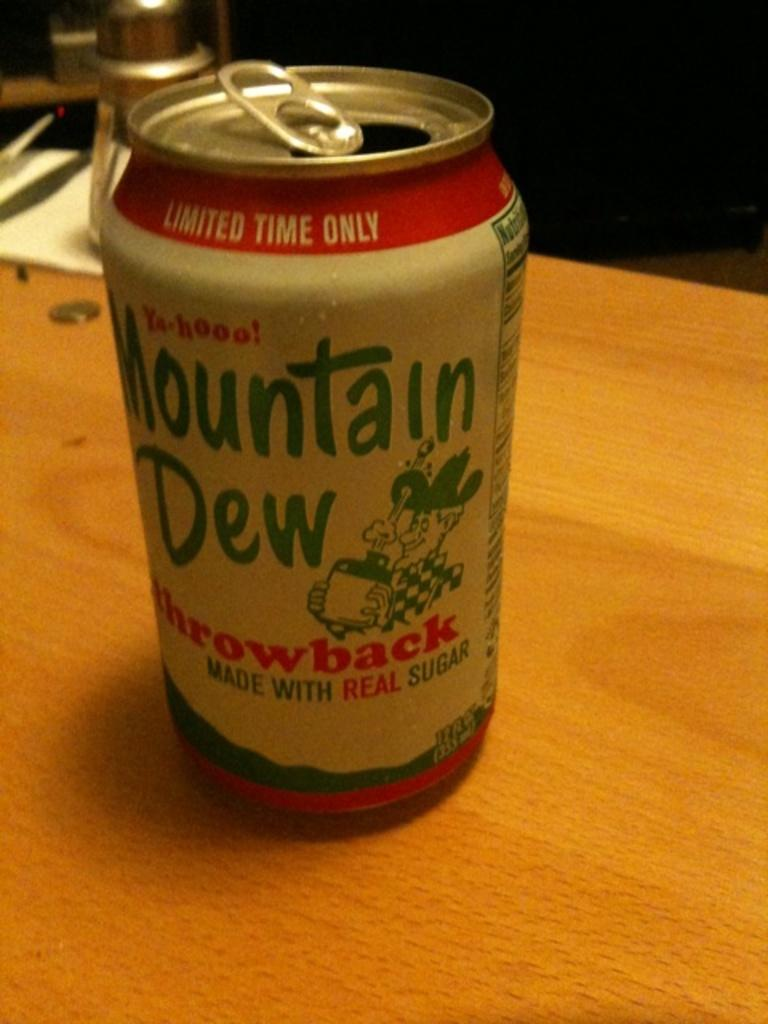<image>
Create a compact narrative representing the image presented. A white and red Mountain Dew throwback can on a table. 